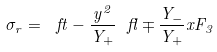<formula> <loc_0><loc_0><loc_500><loc_500>\sigma _ { r } = \ f t - \frac { y ^ { 2 } } { Y _ { + } } \ f l \mp \frac { Y _ { - } } { Y _ { + } } x F _ { 3 }</formula> 